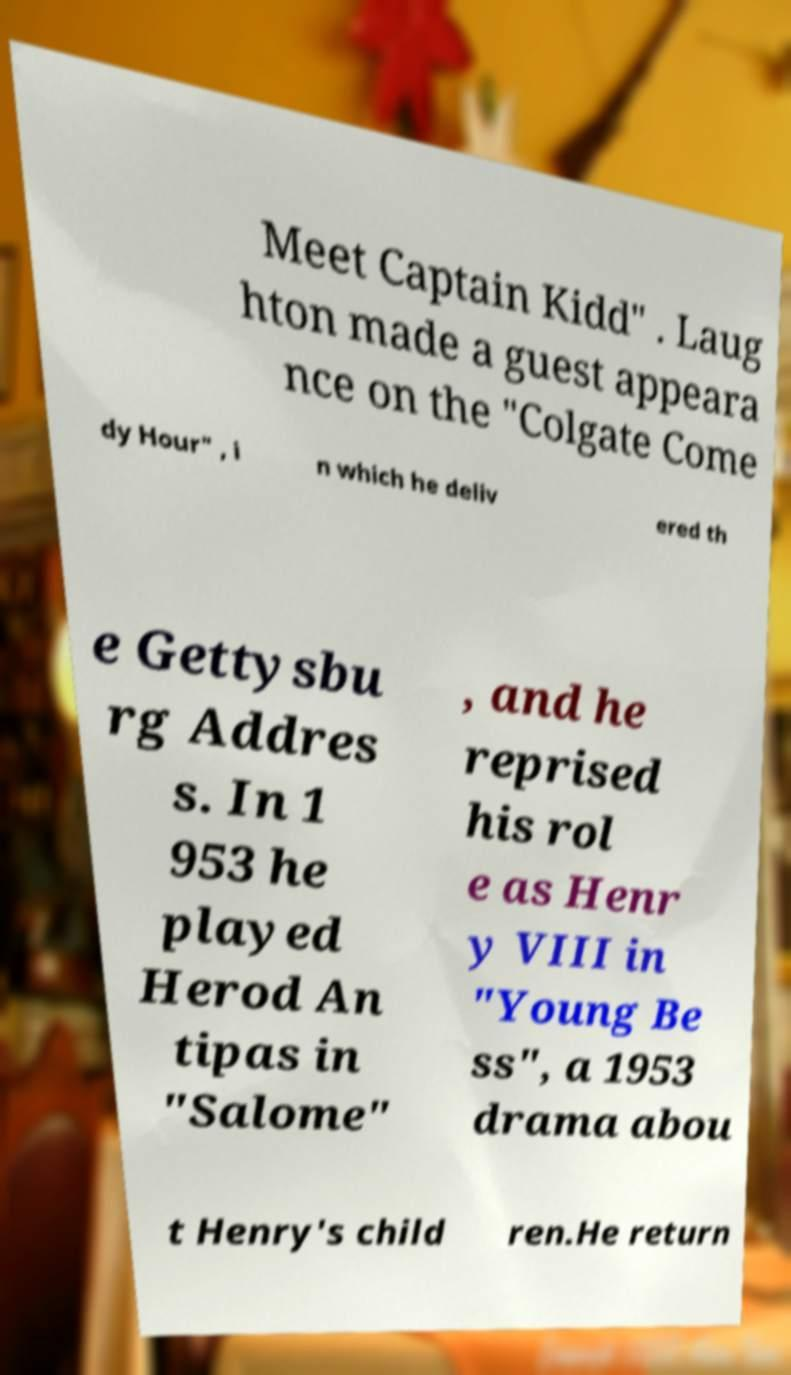Could you extract and type out the text from this image? Meet Captain Kidd" . Laug hton made a guest appeara nce on the "Colgate Come dy Hour" , i n which he deliv ered th e Gettysbu rg Addres s. In 1 953 he played Herod An tipas in "Salome" , and he reprised his rol e as Henr y VIII in "Young Be ss", a 1953 drama abou t Henry's child ren.He return 